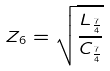Convert formula to latex. <formula><loc_0><loc_0><loc_500><loc_500>Z _ { 6 } = \sqrt { \frac { L _ { \frac { 7 } { 4 } } } { C _ { \frac { 7 } { 4 } } } }</formula> 